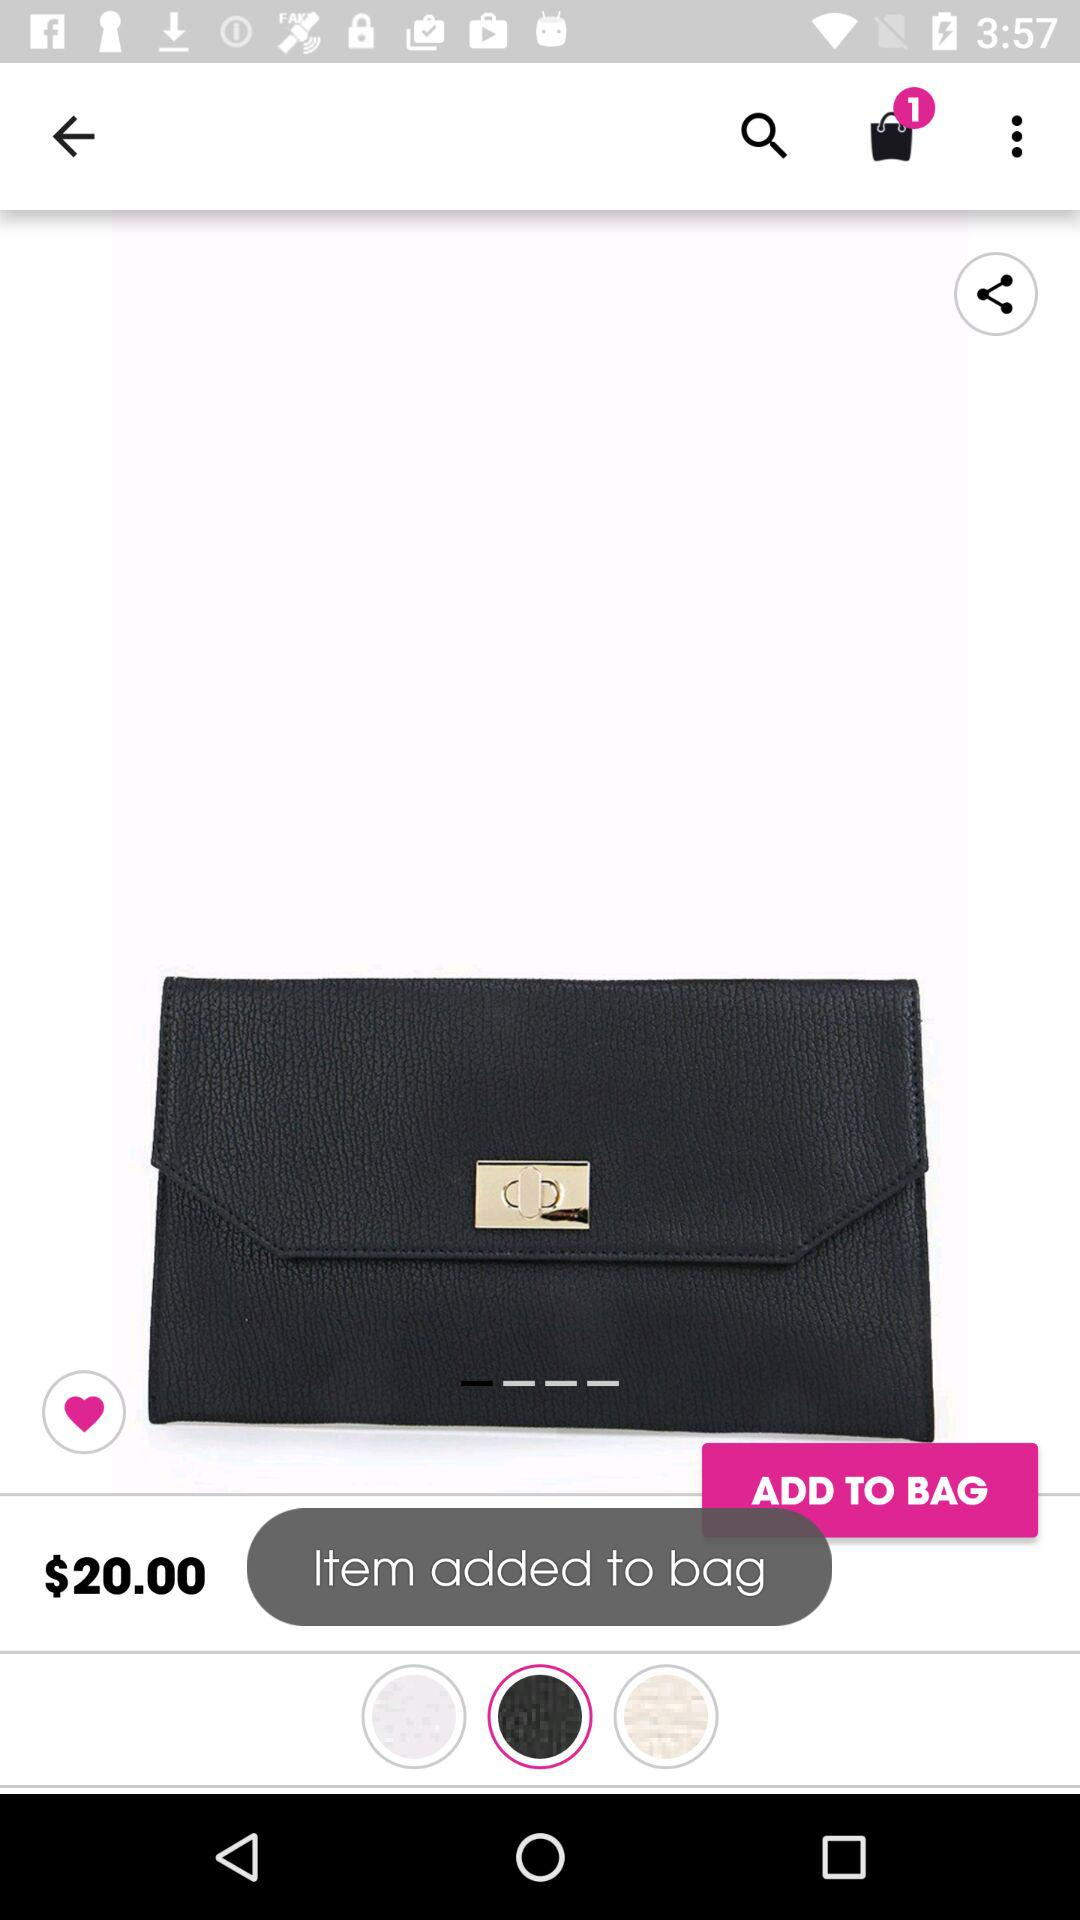What is the price of the bag? The price of the bag is $20. 